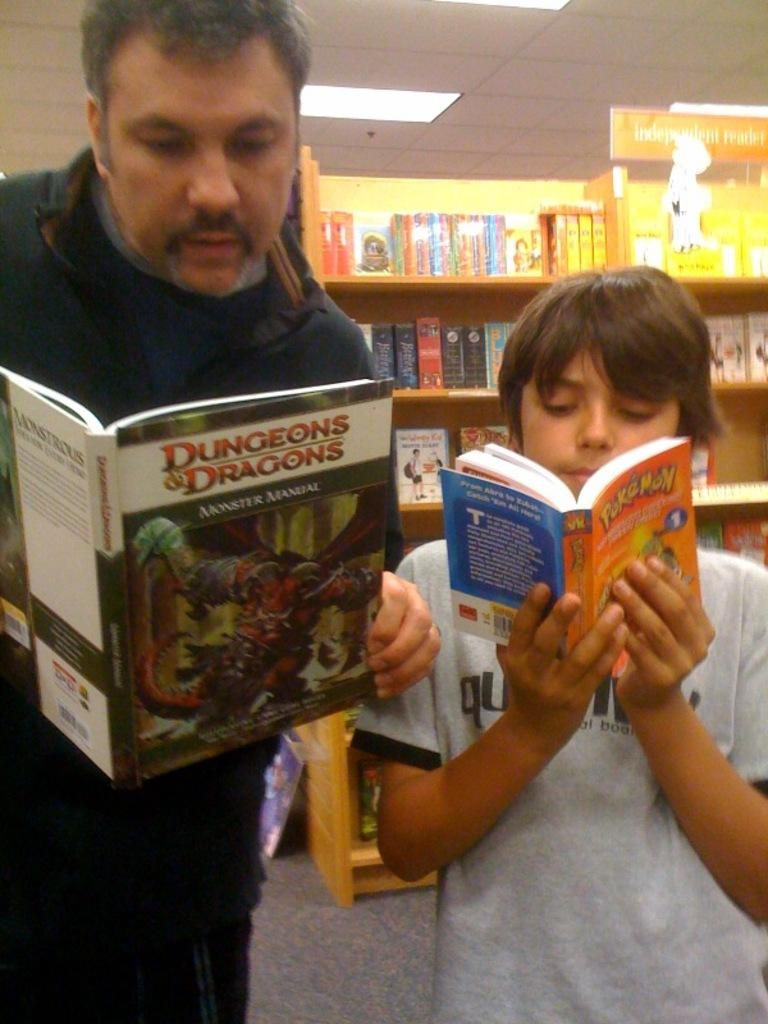Provide a one-sentence caption for the provided image. A man is reading a dungeons and dragons book and a child is reading a pokemon book. 